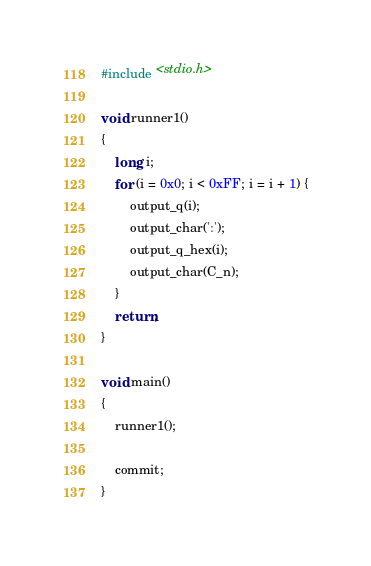<code> <loc_0><loc_0><loc_500><loc_500><_C_>#include <stdio.h>

void runner1()
{
    long i;
    for (i = 0x0; i < 0xFF; i = i + 1) {
        output_q(i);
        output_char(':');
        output_q_hex(i);
        output_char(C_n);
    }
    return;
}

void main()
{
    runner1();

    commit;
}


</code> 